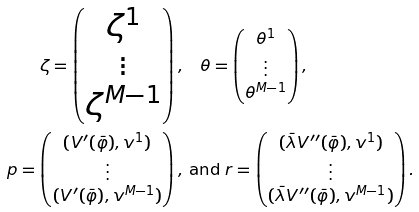<formula> <loc_0><loc_0><loc_500><loc_500>\zeta = \begin{pmatrix} \zeta ^ { 1 } \\ \vdots \\ \zeta ^ { M - 1 } \end{pmatrix} , & \quad \theta = \begin{pmatrix} \theta ^ { 1 } \\ \vdots \\ \theta ^ { M - 1 } \end{pmatrix} , \\ p = \begin{pmatrix} ( V ^ { \prime } ( \bar { \varphi } ) , v ^ { 1 } ) \\ \vdots \\ ( V ^ { \prime } ( \bar { \varphi } ) , v ^ { M - 1 } ) \end{pmatrix} , & \ \text {and} \ r = \begin{pmatrix} ( \bar { \lambda } V ^ { \prime \prime } ( \bar { \varphi } ) , v ^ { 1 } ) \\ \vdots \\ ( \bar { \lambda } V ^ { \prime \prime } ( \bar { \varphi } ) , v ^ { M - 1 } ) \end{pmatrix} .</formula> 